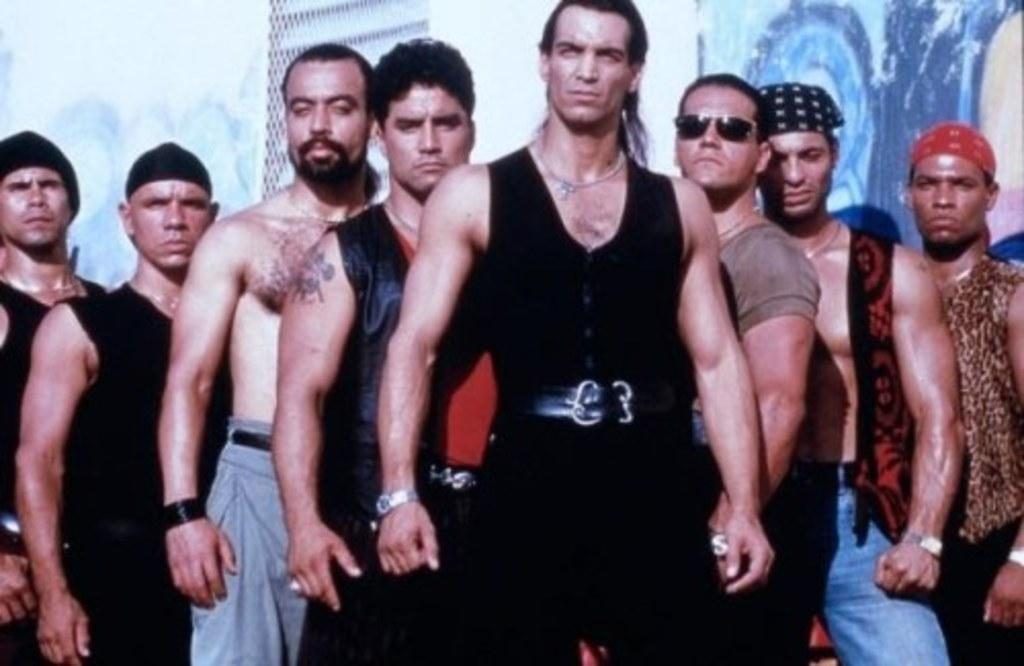What is happening in the center of the image? There are people standing in the center of the image. What can be seen in the background of the image? There is a board and a mesh in the background of the image. How much debt do the people in the image owe to the quicksand? There is no quicksand present in the image, and therefore no debt can be associated with it. 